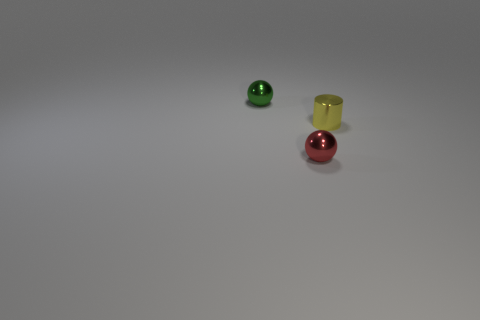What is the shape of the small metal object that is both on the left side of the small cylinder and behind the small red metal thing?
Give a very brief answer. Sphere. Does the sphere that is behind the tiny red ball have the same material as the tiny red sphere?
Offer a terse response. Yes. How many objects are either large yellow cylinders or balls that are on the right side of the green sphere?
Ensure brevity in your answer.  1. There is another ball that is the same material as the red ball; what color is it?
Your answer should be very brief. Green. What number of yellow spheres are the same material as the tiny cylinder?
Your response must be concise. 0. What number of tiny purple metallic balls are there?
Your answer should be very brief. 0. There is a small metal ball that is in front of the yellow metal cylinder; does it have the same color as the shiny sphere that is behind the small yellow metal cylinder?
Your response must be concise. No. How many red metal spheres are right of the small red metallic object?
Your response must be concise. 0. Is there another small yellow rubber thing that has the same shape as the small yellow thing?
Your answer should be very brief. No. Does the small green object on the left side of the small red thing have the same material as the small ball to the right of the tiny green sphere?
Give a very brief answer. Yes. 